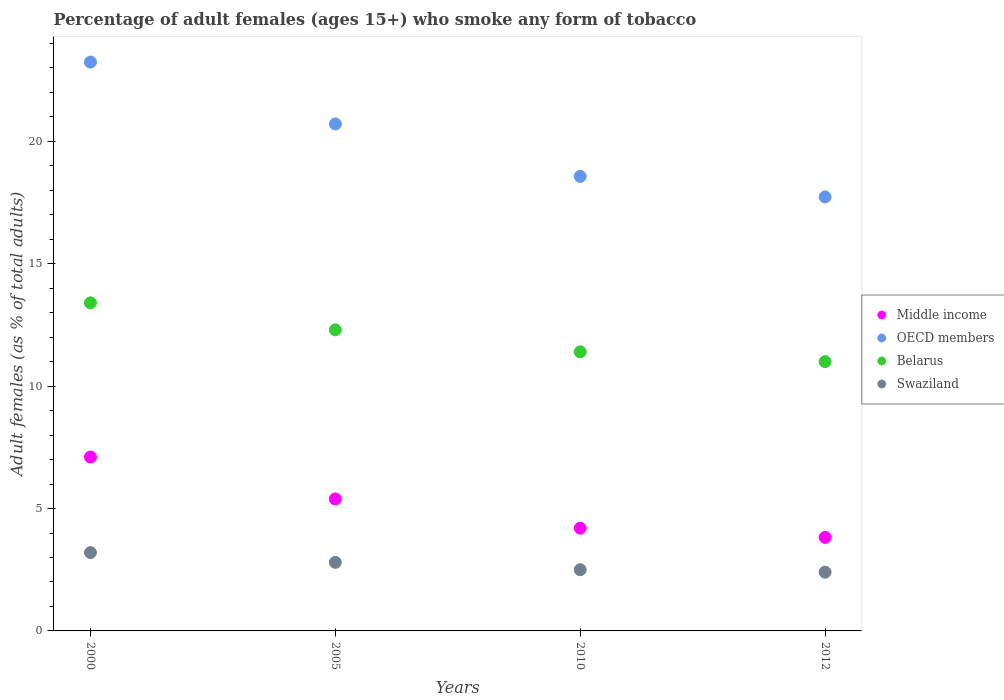How many different coloured dotlines are there?
Make the answer very short. 4. What is the percentage of adult females who smoke in Middle income in 2012?
Make the answer very short. 3.82. Across all years, what is the maximum percentage of adult females who smoke in Swaziland?
Make the answer very short. 3.2. Across all years, what is the minimum percentage of adult females who smoke in Swaziland?
Provide a short and direct response. 2.4. What is the total percentage of adult females who smoke in Belarus in the graph?
Make the answer very short. 48.1. What is the difference between the percentage of adult females who smoke in Middle income in 2005 and that in 2012?
Offer a terse response. 1.57. What is the difference between the percentage of adult females who smoke in Belarus in 2000 and the percentage of adult females who smoke in Swaziland in 2012?
Make the answer very short. 11. What is the average percentage of adult females who smoke in Middle income per year?
Make the answer very short. 5.13. In the year 2000, what is the difference between the percentage of adult females who smoke in OECD members and percentage of adult females who smoke in Swaziland?
Offer a very short reply. 20.04. What is the ratio of the percentage of adult females who smoke in OECD members in 2010 to that in 2012?
Offer a terse response. 1.05. Is the percentage of adult females who smoke in OECD members in 2005 less than that in 2012?
Make the answer very short. No. Is the difference between the percentage of adult females who smoke in OECD members in 2010 and 2012 greater than the difference between the percentage of adult females who smoke in Swaziland in 2010 and 2012?
Ensure brevity in your answer.  Yes. What is the difference between the highest and the second highest percentage of adult females who smoke in Middle income?
Keep it short and to the point. 1.71. What is the difference between the highest and the lowest percentage of adult females who smoke in OECD members?
Provide a succinct answer. 5.51. In how many years, is the percentage of adult females who smoke in Belarus greater than the average percentage of adult females who smoke in Belarus taken over all years?
Provide a succinct answer. 2. Is the percentage of adult females who smoke in Swaziland strictly greater than the percentage of adult females who smoke in Middle income over the years?
Make the answer very short. No. Does the graph contain any zero values?
Your response must be concise. No. How many legend labels are there?
Offer a very short reply. 4. What is the title of the graph?
Your response must be concise. Percentage of adult females (ages 15+) who smoke any form of tobacco. Does "Sub-Saharan Africa (developing only)" appear as one of the legend labels in the graph?
Give a very brief answer. No. What is the label or title of the X-axis?
Ensure brevity in your answer.  Years. What is the label or title of the Y-axis?
Offer a terse response. Adult females (as % of total adults). What is the Adult females (as % of total adults) in Middle income in 2000?
Ensure brevity in your answer.  7.1. What is the Adult females (as % of total adults) in OECD members in 2000?
Your answer should be very brief. 23.24. What is the Adult females (as % of total adults) of Belarus in 2000?
Provide a succinct answer. 13.4. What is the Adult females (as % of total adults) of Middle income in 2005?
Provide a short and direct response. 5.39. What is the Adult females (as % of total adults) of OECD members in 2005?
Your response must be concise. 20.71. What is the Adult females (as % of total adults) in Swaziland in 2005?
Provide a succinct answer. 2.8. What is the Adult females (as % of total adults) of Middle income in 2010?
Offer a very short reply. 4.2. What is the Adult females (as % of total adults) of OECD members in 2010?
Your answer should be compact. 18.57. What is the Adult females (as % of total adults) in Middle income in 2012?
Provide a succinct answer. 3.82. What is the Adult females (as % of total adults) in OECD members in 2012?
Offer a very short reply. 17.73. What is the Adult females (as % of total adults) in Belarus in 2012?
Provide a short and direct response. 11. Across all years, what is the maximum Adult females (as % of total adults) of Middle income?
Provide a short and direct response. 7.1. Across all years, what is the maximum Adult females (as % of total adults) of OECD members?
Your answer should be very brief. 23.24. Across all years, what is the maximum Adult females (as % of total adults) of Belarus?
Your answer should be very brief. 13.4. Across all years, what is the maximum Adult females (as % of total adults) in Swaziland?
Offer a terse response. 3.2. Across all years, what is the minimum Adult females (as % of total adults) of Middle income?
Offer a very short reply. 3.82. Across all years, what is the minimum Adult females (as % of total adults) of OECD members?
Keep it short and to the point. 17.73. What is the total Adult females (as % of total adults) of Middle income in the graph?
Keep it short and to the point. 20.51. What is the total Adult females (as % of total adults) in OECD members in the graph?
Offer a very short reply. 80.24. What is the total Adult females (as % of total adults) of Belarus in the graph?
Offer a terse response. 48.1. What is the difference between the Adult females (as % of total adults) of Middle income in 2000 and that in 2005?
Your answer should be compact. 1.71. What is the difference between the Adult females (as % of total adults) in OECD members in 2000 and that in 2005?
Provide a short and direct response. 2.53. What is the difference between the Adult females (as % of total adults) in Belarus in 2000 and that in 2005?
Make the answer very short. 1.1. What is the difference between the Adult females (as % of total adults) in Swaziland in 2000 and that in 2005?
Offer a very short reply. 0.4. What is the difference between the Adult females (as % of total adults) in Middle income in 2000 and that in 2010?
Provide a short and direct response. 2.91. What is the difference between the Adult females (as % of total adults) of OECD members in 2000 and that in 2010?
Provide a succinct answer. 4.67. What is the difference between the Adult females (as % of total adults) in Belarus in 2000 and that in 2010?
Give a very brief answer. 2. What is the difference between the Adult females (as % of total adults) in Swaziland in 2000 and that in 2010?
Your response must be concise. 0.7. What is the difference between the Adult females (as % of total adults) in Middle income in 2000 and that in 2012?
Keep it short and to the point. 3.28. What is the difference between the Adult females (as % of total adults) of OECD members in 2000 and that in 2012?
Your answer should be very brief. 5.51. What is the difference between the Adult females (as % of total adults) of Belarus in 2000 and that in 2012?
Offer a terse response. 2.4. What is the difference between the Adult females (as % of total adults) in Swaziland in 2000 and that in 2012?
Provide a succinct answer. 0.8. What is the difference between the Adult females (as % of total adults) of Middle income in 2005 and that in 2010?
Give a very brief answer. 1.19. What is the difference between the Adult females (as % of total adults) of OECD members in 2005 and that in 2010?
Your answer should be very brief. 2.14. What is the difference between the Adult females (as % of total adults) of Belarus in 2005 and that in 2010?
Make the answer very short. 0.9. What is the difference between the Adult females (as % of total adults) of Middle income in 2005 and that in 2012?
Provide a short and direct response. 1.57. What is the difference between the Adult females (as % of total adults) in OECD members in 2005 and that in 2012?
Offer a very short reply. 2.98. What is the difference between the Adult females (as % of total adults) in Middle income in 2010 and that in 2012?
Keep it short and to the point. 0.37. What is the difference between the Adult females (as % of total adults) in OECD members in 2010 and that in 2012?
Make the answer very short. 0.84. What is the difference between the Adult females (as % of total adults) in Swaziland in 2010 and that in 2012?
Give a very brief answer. 0.1. What is the difference between the Adult females (as % of total adults) of Middle income in 2000 and the Adult females (as % of total adults) of OECD members in 2005?
Provide a succinct answer. -13.61. What is the difference between the Adult females (as % of total adults) in Middle income in 2000 and the Adult females (as % of total adults) in Belarus in 2005?
Offer a very short reply. -5.2. What is the difference between the Adult females (as % of total adults) in Middle income in 2000 and the Adult females (as % of total adults) in Swaziland in 2005?
Provide a short and direct response. 4.3. What is the difference between the Adult females (as % of total adults) of OECD members in 2000 and the Adult females (as % of total adults) of Belarus in 2005?
Give a very brief answer. 10.94. What is the difference between the Adult females (as % of total adults) of OECD members in 2000 and the Adult females (as % of total adults) of Swaziland in 2005?
Offer a very short reply. 20.44. What is the difference between the Adult females (as % of total adults) in Belarus in 2000 and the Adult females (as % of total adults) in Swaziland in 2005?
Offer a very short reply. 10.6. What is the difference between the Adult females (as % of total adults) in Middle income in 2000 and the Adult females (as % of total adults) in OECD members in 2010?
Make the answer very short. -11.46. What is the difference between the Adult females (as % of total adults) of Middle income in 2000 and the Adult females (as % of total adults) of Belarus in 2010?
Your response must be concise. -4.3. What is the difference between the Adult females (as % of total adults) of Middle income in 2000 and the Adult females (as % of total adults) of Swaziland in 2010?
Keep it short and to the point. 4.6. What is the difference between the Adult females (as % of total adults) in OECD members in 2000 and the Adult females (as % of total adults) in Belarus in 2010?
Give a very brief answer. 11.84. What is the difference between the Adult females (as % of total adults) in OECD members in 2000 and the Adult females (as % of total adults) in Swaziland in 2010?
Keep it short and to the point. 20.74. What is the difference between the Adult females (as % of total adults) in Belarus in 2000 and the Adult females (as % of total adults) in Swaziland in 2010?
Keep it short and to the point. 10.9. What is the difference between the Adult females (as % of total adults) in Middle income in 2000 and the Adult females (as % of total adults) in OECD members in 2012?
Keep it short and to the point. -10.62. What is the difference between the Adult females (as % of total adults) in Middle income in 2000 and the Adult females (as % of total adults) in Belarus in 2012?
Your answer should be compact. -3.9. What is the difference between the Adult females (as % of total adults) of Middle income in 2000 and the Adult females (as % of total adults) of Swaziland in 2012?
Your response must be concise. 4.7. What is the difference between the Adult females (as % of total adults) of OECD members in 2000 and the Adult females (as % of total adults) of Belarus in 2012?
Your answer should be very brief. 12.24. What is the difference between the Adult females (as % of total adults) in OECD members in 2000 and the Adult females (as % of total adults) in Swaziland in 2012?
Offer a very short reply. 20.84. What is the difference between the Adult females (as % of total adults) of Belarus in 2000 and the Adult females (as % of total adults) of Swaziland in 2012?
Make the answer very short. 11. What is the difference between the Adult females (as % of total adults) of Middle income in 2005 and the Adult females (as % of total adults) of OECD members in 2010?
Give a very brief answer. -13.18. What is the difference between the Adult females (as % of total adults) of Middle income in 2005 and the Adult females (as % of total adults) of Belarus in 2010?
Your response must be concise. -6.01. What is the difference between the Adult females (as % of total adults) in Middle income in 2005 and the Adult females (as % of total adults) in Swaziland in 2010?
Your answer should be compact. 2.89. What is the difference between the Adult females (as % of total adults) in OECD members in 2005 and the Adult females (as % of total adults) in Belarus in 2010?
Keep it short and to the point. 9.31. What is the difference between the Adult females (as % of total adults) of OECD members in 2005 and the Adult females (as % of total adults) of Swaziland in 2010?
Ensure brevity in your answer.  18.21. What is the difference between the Adult females (as % of total adults) in Middle income in 2005 and the Adult females (as % of total adults) in OECD members in 2012?
Your answer should be very brief. -12.34. What is the difference between the Adult females (as % of total adults) of Middle income in 2005 and the Adult females (as % of total adults) of Belarus in 2012?
Make the answer very short. -5.61. What is the difference between the Adult females (as % of total adults) of Middle income in 2005 and the Adult females (as % of total adults) of Swaziland in 2012?
Offer a very short reply. 2.99. What is the difference between the Adult females (as % of total adults) in OECD members in 2005 and the Adult females (as % of total adults) in Belarus in 2012?
Offer a terse response. 9.71. What is the difference between the Adult females (as % of total adults) in OECD members in 2005 and the Adult females (as % of total adults) in Swaziland in 2012?
Keep it short and to the point. 18.31. What is the difference between the Adult females (as % of total adults) in Belarus in 2005 and the Adult females (as % of total adults) in Swaziland in 2012?
Your response must be concise. 9.9. What is the difference between the Adult females (as % of total adults) in Middle income in 2010 and the Adult females (as % of total adults) in OECD members in 2012?
Your answer should be compact. -13.53. What is the difference between the Adult females (as % of total adults) of Middle income in 2010 and the Adult females (as % of total adults) of Belarus in 2012?
Provide a short and direct response. -6.8. What is the difference between the Adult females (as % of total adults) of Middle income in 2010 and the Adult females (as % of total adults) of Swaziland in 2012?
Give a very brief answer. 1.8. What is the difference between the Adult females (as % of total adults) in OECD members in 2010 and the Adult females (as % of total adults) in Belarus in 2012?
Offer a terse response. 7.57. What is the difference between the Adult females (as % of total adults) in OECD members in 2010 and the Adult females (as % of total adults) in Swaziland in 2012?
Offer a terse response. 16.17. What is the average Adult females (as % of total adults) in Middle income per year?
Provide a succinct answer. 5.13. What is the average Adult females (as % of total adults) of OECD members per year?
Give a very brief answer. 20.06. What is the average Adult females (as % of total adults) of Belarus per year?
Offer a very short reply. 12.03. What is the average Adult females (as % of total adults) of Swaziland per year?
Make the answer very short. 2.73. In the year 2000, what is the difference between the Adult females (as % of total adults) of Middle income and Adult females (as % of total adults) of OECD members?
Offer a terse response. -16.13. In the year 2000, what is the difference between the Adult females (as % of total adults) in Middle income and Adult females (as % of total adults) in Belarus?
Ensure brevity in your answer.  -6.3. In the year 2000, what is the difference between the Adult females (as % of total adults) in Middle income and Adult females (as % of total adults) in Swaziland?
Offer a very short reply. 3.9. In the year 2000, what is the difference between the Adult females (as % of total adults) of OECD members and Adult females (as % of total adults) of Belarus?
Ensure brevity in your answer.  9.84. In the year 2000, what is the difference between the Adult females (as % of total adults) in OECD members and Adult females (as % of total adults) in Swaziland?
Give a very brief answer. 20.04. In the year 2005, what is the difference between the Adult females (as % of total adults) of Middle income and Adult females (as % of total adults) of OECD members?
Provide a succinct answer. -15.32. In the year 2005, what is the difference between the Adult females (as % of total adults) in Middle income and Adult females (as % of total adults) in Belarus?
Make the answer very short. -6.91. In the year 2005, what is the difference between the Adult females (as % of total adults) in Middle income and Adult females (as % of total adults) in Swaziland?
Your answer should be compact. 2.59. In the year 2005, what is the difference between the Adult females (as % of total adults) in OECD members and Adult females (as % of total adults) in Belarus?
Offer a terse response. 8.41. In the year 2005, what is the difference between the Adult females (as % of total adults) of OECD members and Adult females (as % of total adults) of Swaziland?
Ensure brevity in your answer.  17.91. In the year 2005, what is the difference between the Adult females (as % of total adults) in Belarus and Adult females (as % of total adults) in Swaziland?
Your response must be concise. 9.5. In the year 2010, what is the difference between the Adult females (as % of total adults) in Middle income and Adult females (as % of total adults) in OECD members?
Provide a succinct answer. -14.37. In the year 2010, what is the difference between the Adult females (as % of total adults) of Middle income and Adult females (as % of total adults) of Belarus?
Ensure brevity in your answer.  -7.2. In the year 2010, what is the difference between the Adult females (as % of total adults) in Middle income and Adult females (as % of total adults) in Swaziland?
Provide a short and direct response. 1.7. In the year 2010, what is the difference between the Adult females (as % of total adults) in OECD members and Adult females (as % of total adults) in Belarus?
Ensure brevity in your answer.  7.17. In the year 2010, what is the difference between the Adult females (as % of total adults) of OECD members and Adult females (as % of total adults) of Swaziland?
Offer a terse response. 16.07. In the year 2010, what is the difference between the Adult females (as % of total adults) in Belarus and Adult females (as % of total adults) in Swaziland?
Give a very brief answer. 8.9. In the year 2012, what is the difference between the Adult females (as % of total adults) in Middle income and Adult females (as % of total adults) in OECD members?
Make the answer very short. -13.91. In the year 2012, what is the difference between the Adult females (as % of total adults) of Middle income and Adult females (as % of total adults) of Belarus?
Provide a succinct answer. -7.18. In the year 2012, what is the difference between the Adult females (as % of total adults) of Middle income and Adult females (as % of total adults) of Swaziland?
Your answer should be very brief. 1.42. In the year 2012, what is the difference between the Adult females (as % of total adults) of OECD members and Adult females (as % of total adults) of Belarus?
Provide a succinct answer. 6.73. In the year 2012, what is the difference between the Adult females (as % of total adults) in OECD members and Adult females (as % of total adults) in Swaziland?
Offer a very short reply. 15.33. What is the ratio of the Adult females (as % of total adults) of Middle income in 2000 to that in 2005?
Offer a terse response. 1.32. What is the ratio of the Adult females (as % of total adults) in OECD members in 2000 to that in 2005?
Provide a short and direct response. 1.12. What is the ratio of the Adult females (as % of total adults) of Belarus in 2000 to that in 2005?
Ensure brevity in your answer.  1.09. What is the ratio of the Adult females (as % of total adults) of Swaziland in 2000 to that in 2005?
Make the answer very short. 1.14. What is the ratio of the Adult females (as % of total adults) of Middle income in 2000 to that in 2010?
Offer a very short reply. 1.69. What is the ratio of the Adult females (as % of total adults) of OECD members in 2000 to that in 2010?
Provide a succinct answer. 1.25. What is the ratio of the Adult females (as % of total adults) in Belarus in 2000 to that in 2010?
Offer a very short reply. 1.18. What is the ratio of the Adult females (as % of total adults) of Swaziland in 2000 to that in 2010?
Offer a terse response. 1.28. What is the ratio of the Adult females (as % of total adults) of Middle income in 2000 to that in 2012?
Offer a very short reply. 1.86. What is the ratio of the Adult females (as % of total adults) in OECD members in 2000 to that in 2012?
Your answer should be very brief. 1.31. What is the ratio of the Adult females (as % of total adults) in Belarus in 2000 to that in 2012?
Provide a short and direct response. 1.22. What is the ratio of the Adult females (as % of total adults) of Middle income in 2005 to that in 2010?
Make the answer very short. 1.28. What is the ratio of the Adult females (as % of total adults) in OECD members in 2005 to that in 2010?
Give a very brief answer. 1.12. What is the ratio of the Adult females (as % of total adults) in Belarus in 2005 to that in 2010?
Give a very brief answer. 1.08. What is the ratio of the Adult females (as % of total adults) in Swaziland in 2005 to that in 2010?
Provide a short and direct response. 1.12. What is the ratio of the Adult females (as % of total adults) of Middle income in 2005 to that in 2012?
Provide a short and direct response. 1.41. What is the ratio of the Adult females (as % of total adults) of OECD members in 2005 to that in 2012?
Your response must be concise. 1.17. What is the ratio of the Adult females (as % of total adults) of Belarus in 2005 to that in 2012?
Ensure brevity in your answer.  1.12. What is the ratio of the Adult females (as % of total adults) in Middle income in 2010 to that in 2012?
Keep it short and to the point. 1.1. What is the ratio of the Adult females (as % of total adults) in OECD members in 2010 to that in 2012?
Provide a succinct answer. 1.05. What is the ratio of the Adult females (as % of total adults) in Belarus in 2010 to that in 2012?
Ensure brevity in your answer.  1.04. What is the ratio of the Adult females (as % of total adults) of Swaziland in 2010 to that in 2012?
Your response must be concise. 1.04. What is the difference between the highest and the second highest Adult females (as % of total adults) in Middle income?
Offer a terse response. 1.71. What is the difference between the highest and the second highest Adult females (as % of total adults) of OECD members?
Give a very brief answer. 2.53. What is the difference between the highest and the second highest Adult females (as % of total adults) in Belarus?
Your answer should be compact. 1.1. What is the difference between the highest and the lowest Adult females (as % of total adults) of Middle income?
Ensure brevity in your answer.  3.28. What is the difference between the highest and the lowest Adult females (as % of total adults) of OECD members?
Give a very brief answer. 5.51. What is the difference between the highest and the lowest Adult females (as % of total adults) of Belarus?
Give a very brief answer. 2.4. 